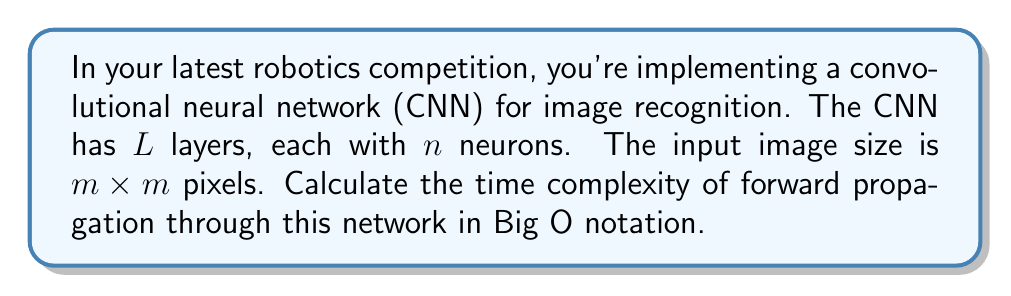Give your solution to this math problem. Let's break this down step-by-step:

1) In a CNN, each layer typically performs a convolution operation followed by an activation function.

2) The convolution operation for each neuron in a layer involves:
   - Sliding a kernel (typically 3x3 or 5x5) over the input
   - Performing element-wise multiplication and summing the results

3) Let's assume a 3x3 kernel for simplicity. For each output pixel, we perform 9 multiplications and 8 additions.

4) The number of operations for one layer is proportional to:
   $$(m-2)^2 \times n \times 17$$
   where $(m-2)^2$ is the output size (reduced by 2 due to the 3x3 kernel), $n$ is the number of neurons, and 17 is the number of operations per output pixel.

5) This simplifies to $O(m^2n)$ for one layer.

6) We have $L$ layers, so we multiply this by $L$:
   $$O(Lm^2n)$$

7) As the image progresses through the network, $m$ typically decreases (due to pooling layers) while $n$ increases. However, for Big O notation, we consider the worst case, which is the largest values of $m$ and $n$.

8) Therefore, the overall time complexity remains $O(Lm^2n)$.
Answer: $O(Lm^2n)$ 